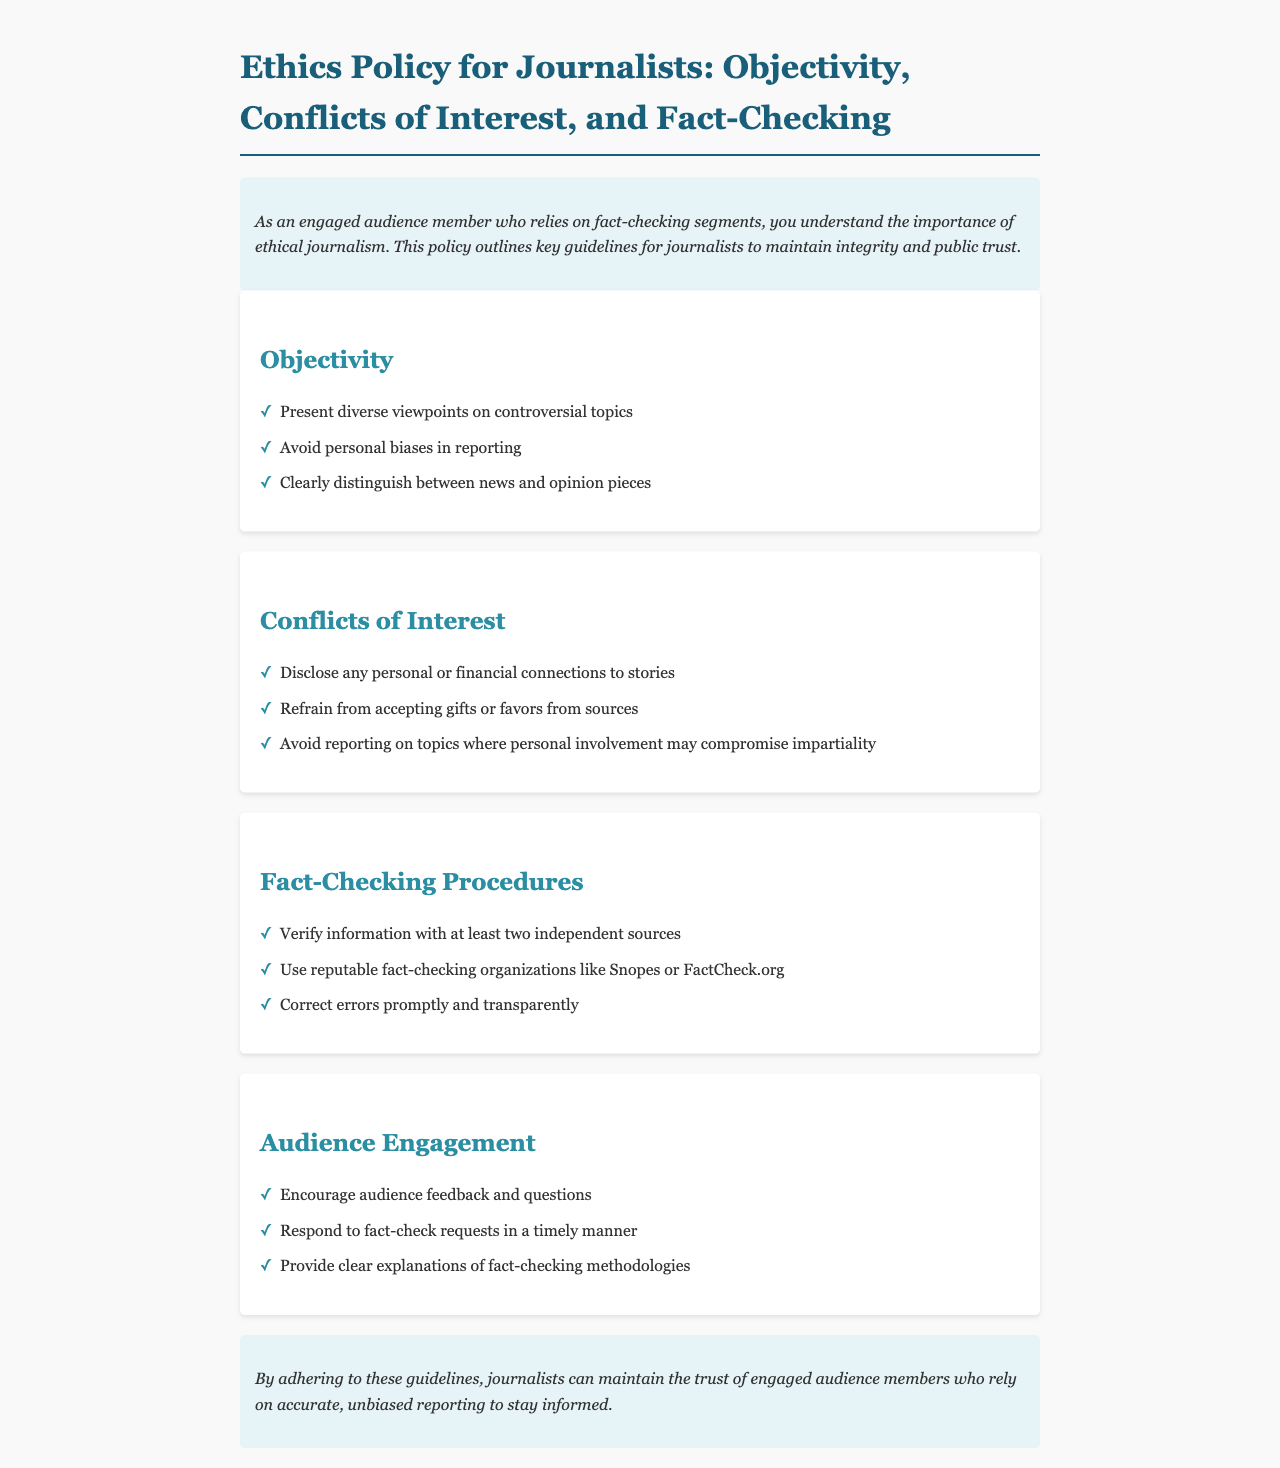What are the three main sections of the ethics policy? The ethics policy consists of the sections on Objectivity, Conflicts of Interest, and Fact-Checking Procedures.
Answer: Objectivity, Conflicts of Interest, Fact-Checking Procedures How should journalists handle personal biases? Journalists should avoid personal biases in reporting to maintain objectivity.
Answer: Avoid personal biases What are the requirements for fact-checking information? Information must be verified with at least two independent sources.
Answer: At least two independent sources What must journalists disclose according to the conflicts of interest section? Journalists must disclose any personal or financial connections to stories.
Answer: Personal or financial connections How should errors be addressed according to the guidelines? Errors should be corrected promptly and transparently.
Answer: Promptly and transparently What is the purpose of the audience engagement section? The audience engagement section encourages interaction and feedback from the audience.
Answer: Interaction and feedback What is a definitive action journalists should refrain from according to the conflicts of interest guidelines? Journalists should refrain from accepting gifts or favors from sources.
Answer: Accepting gifts or favors Which organizations are recommended for fact-checking? Reputable organizations like Snopes or FactCheck.org are recommended for fact-checking.
Answer: Snopes or FactCheck.org How can journalists maintain the trust of their audience? By adhering to the ethics policy guidelines.
Answer: Adhering to the ethics policy guidelines 